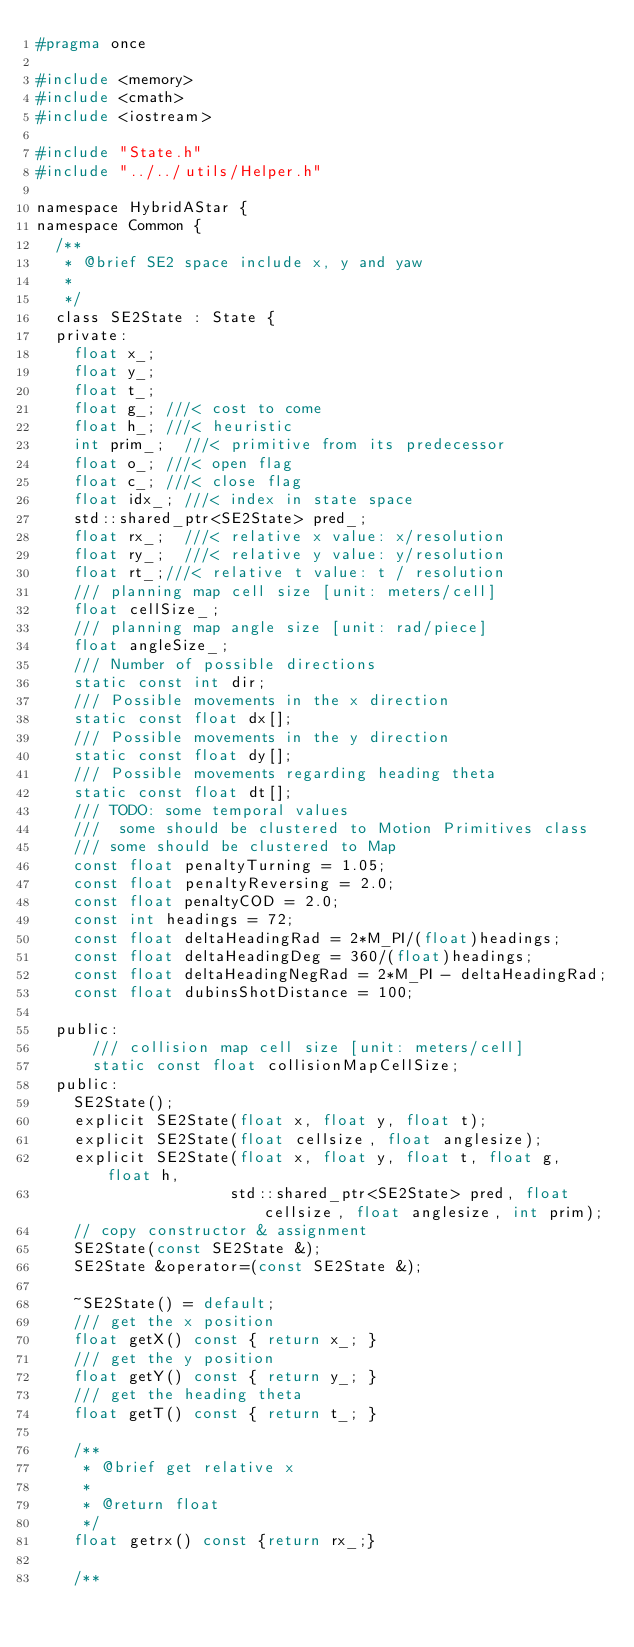Convert code to text. <code><loc_0><loc_0><loc_500><loc_500><_C_>#pragma once

#include <memory>
#include <cmath>
#include <iostream>

#include "State.h"
#include "../../utils/Helper.h"

namespace HybridAStar {
namespace Common {
  /**
   * @brief SE2 space include x, y and yaw
   * 
   */
  class SE2State : State {
  private:
    float x_;
    float y_;
    float t_;
    float g_; ///< cost to come
    float h_; ///< heuristic
    int prim_;  ///< primitive from its predecessor
    float o_; ///< open flag
    float c_; ///< close flag
    float idx_; ///< index in state space
    std::shared_ptr<SE2State> pred_;
    float rx_;  ///< relative x value: x/resolution 
    float ry_;  ///< relative y value: y/resolution
    float rt_;///< relative t value: t / resolution
    /// planning map cell size [unit: meters/cell]
    float cellSize_;
    /// planning map angle size [unit: rad/piece]
    float angleSize_;
    /// Number of possible directions
    static const int dir;
    /// Possible movements in the x direction
    static const float dx[];
    /// Possible movements in the y direction
    static const float dy[];
    /// Possible movements regarding heading theta
    static const float dt[];
    /// TODO: some temporal values
    ///  some should be clustered to Motion Primitives class
    /// some should be clustered to Map
    const float penaltyTurning = 1.05;
    const float penaltyReversing = 2.0;
    const float penaltyCOD = 2.0;
    const int headings = 72;
    const float deltaHeadingRad = 2*M_PI/(float)headings;
    const float deltaHeadingDeg = 360/(float)headings;
    const float deltaHeadingNegRad = 2*M_PI - deltaHeadingRad;
    const float dubinsShotDistance = 100;

  public:
	  /// collision map cell size [unit: meters/cell]
	  static const float collisionMapCellSize;
  public:
    SE2State();
    explicit SE2State(float x, float y, float t);
    explicit SE2State(float cellsize, float anglesize);
    explicit SE2State(float x, float y, float t, float g, float h,
                     std::shared_ptr<SE2State> pred, float cellsize, float anglesize, int prim);
    // copy constructor & assignment
    SE2State(const SE2State &);
    SE2State &operator=(const SE2State &);

    ~SE2State() = default;
    /// get the x position
    float getX() const { return x_; }
    /// get the y position
    float getY() const { return y_; }
    /// get the heading theta
    float getT() const { return t_; }

    /**
     * @brief get relative x
     * 
     * @return float 
     */
    float getrx() const {return rx_;}

    /**</code> 